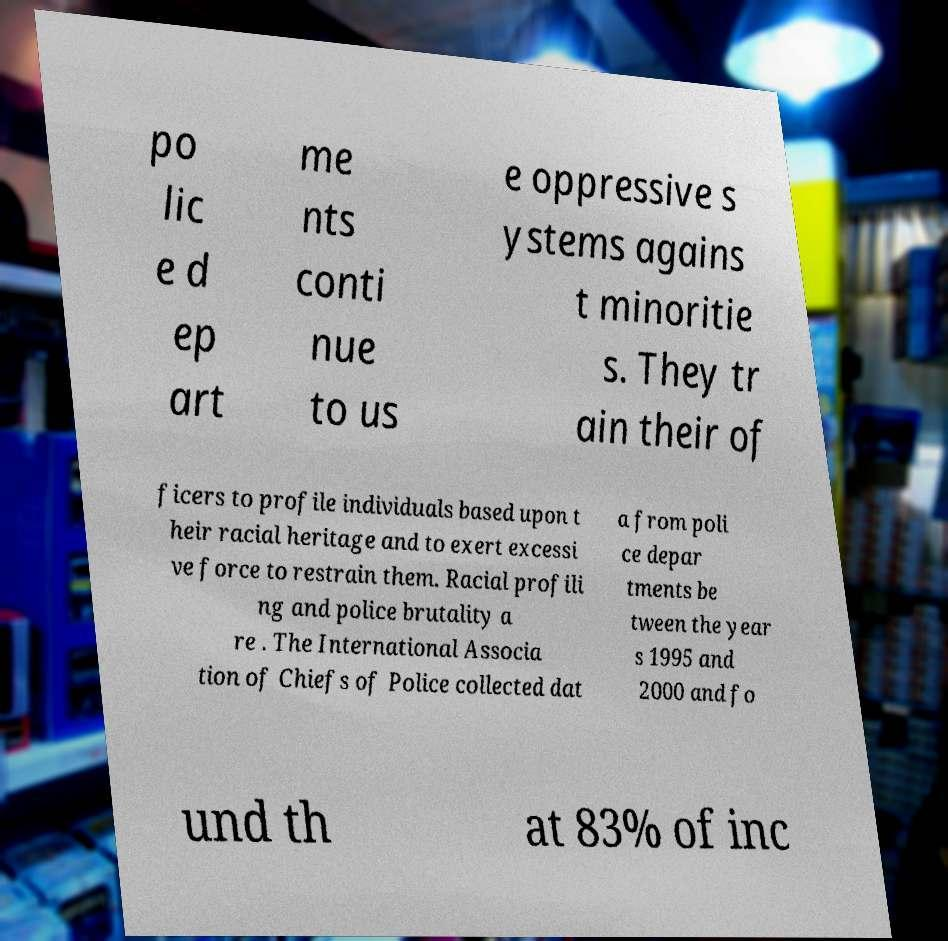Please identify and transcribe the text found in this image. po lic e d ep art me nts conti nue to us e oppressive s ystems agains t minoritie s. They tr ain their of ficers to profile individuals based upon t heir racial heritage and to exert excessi ve force to restrain them. Racial profili ng and police brutality a re . The International Associa tion of Chiefs of Police collected dat a from poli ce depar tments be tween the year s 1995 and 2000 and fo und th at 83% of inc 